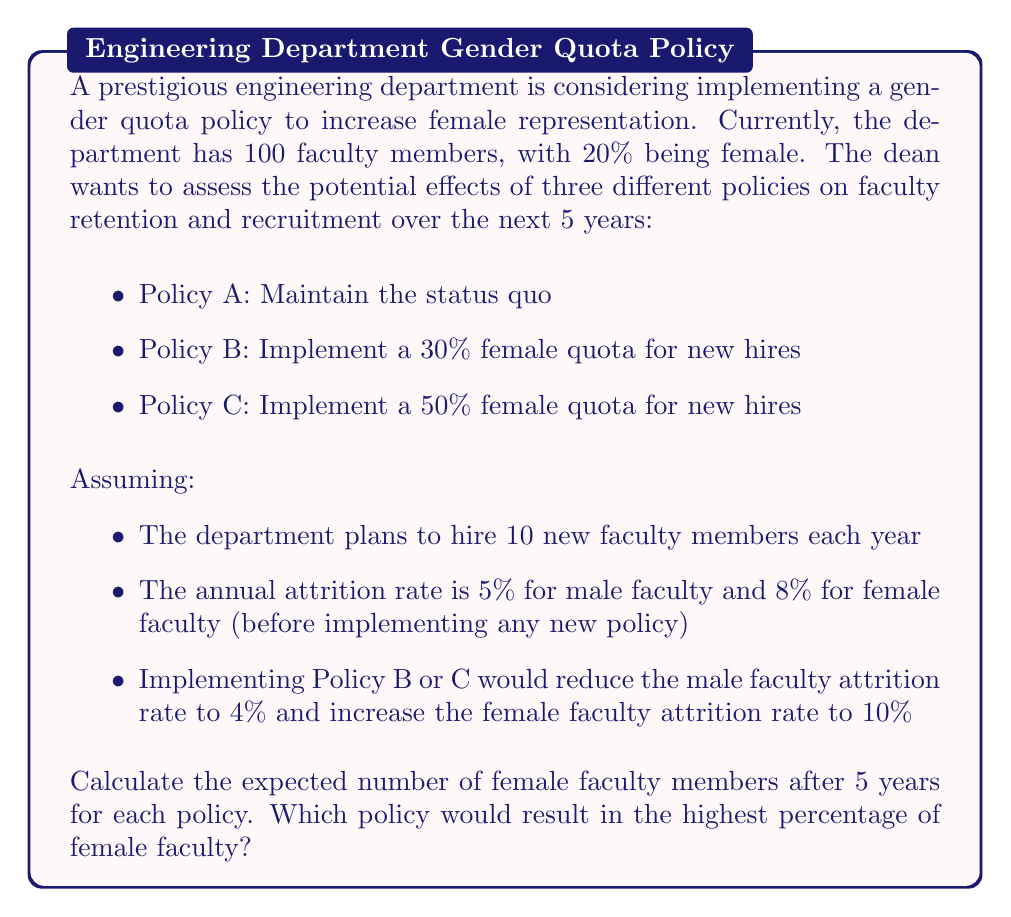Can you answer this question? Let's approach this problem step-by-step for each policy:

1. Initial conditions:
   Total faculty: 100
   Female faculty: 20 (20%)
   Male faculty: 80 (80%)

2. Policy A: Maintain the status quo

   For each year:
   - Male faculty: $80 \times 0.95 = 76$ (after attrition)
   - Female faculty: $20 \times 0.92 = 18.4$ (after attrition)
   - New hires: 10 × 20% = 2 females, 8 males

   After 5 years:
   Male faculty: $80 \times 0.95^5 + 8 \times (1 + 0.95 + 0.95^2 + 0.95^3 + 0.95^4) = 80.78$
   Female faculty: $20 \times 0.92^5 + 2 \times (1 + 0.92 + 0.92^2 + 0.92^3 + 0.92^4) = 22.93$

3. Policy B: 30% female quota for new hires

   For each year:
   - Male faculty: $80 \times 0.96 = 76.8$ (after attrition)
   - Female faculty: $20 \times 0.90 = 18$ (after attrition)
   - New hires: 3 females, 7 males

   After 5 years:
   Male faculty: $80 \times 0.96^5 + 7 \times (1 + 0.96 + 0.96^2 + 0.96^3 + 0.96^4) = 81.92$
   Female faculty: $20 \times 0.90^5 + 3 \times (1 + 0.90 + 0.90^2 + 0.90^3 + 0.90^4) = 26.24$

4. Policy C: 50% female quota for new hires

   For each year:
   - Male faculty: $80 \times 0.96 = 76.8$ (after attrition)
   - Female faculty: $20 \times 0.90 = 18$ (after attrition)
   - New hires: 5 females, 5 males

   After 5 years:
   Male faculty: $80 \times 0.96^5 + 5 \times (1 + 0.96 + 0.96^2 + 0.96^3 + 0.96^4) = 74.23$
   Female faculty: $20 \times 0.90^5 + 5 \times (1 + 0.90 + 0.90^2 + 0.90^3 + 0.90^4) = 33.73$

5. Calculate percentages:
   Policy A: $22.93 / (22.93 + 80.78) = 22.11\%$
   Policy B: $26.24 / (26.24 + 81.92) = 24.26\%$
   Policy C: $33.73 / (33.73 + 74.23) = 31.25\%$
Answer: After 5 years:
Policy A: 22.93 female faculty (22.11%)
Policy B: 26.24 female faculty (24.26%)
Policy C: 33.73 female faculty (31.25%)

Policy C would result in the highest percentage of female faculty at 31.25%. 